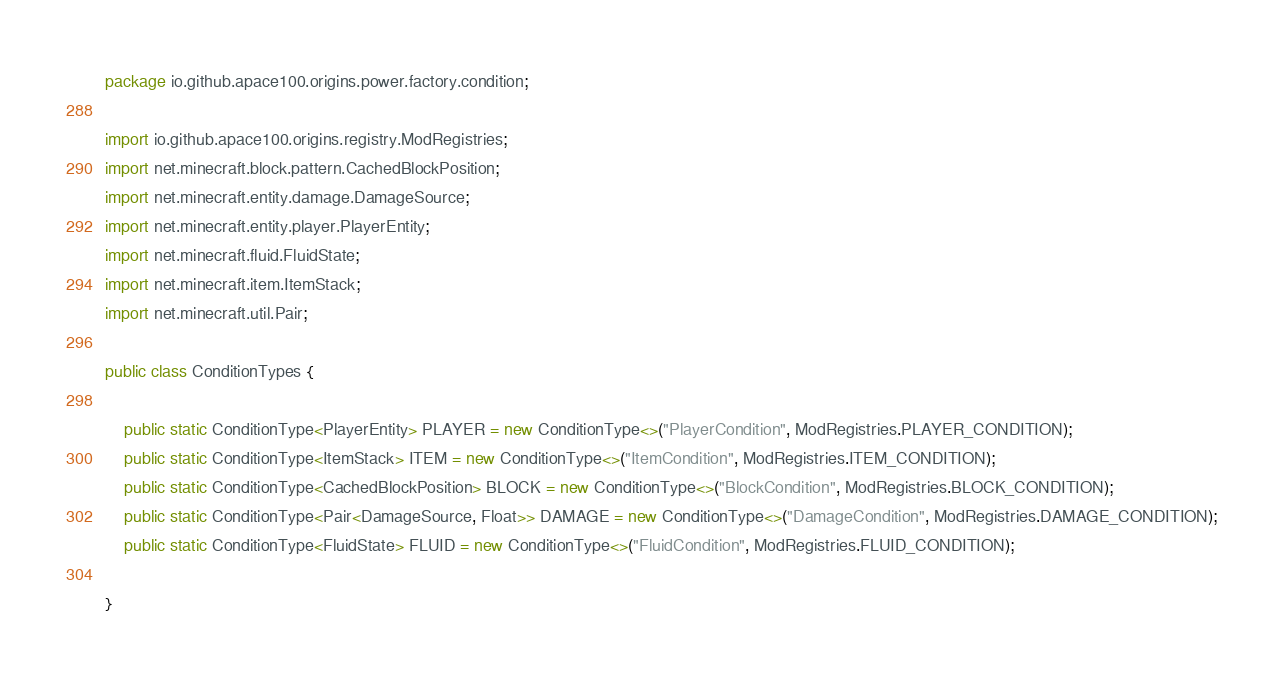Convert code to text. <code><loc_0><loc_0><loc_500><loc_500><_Java_>package io.github.apace100.origins.power.factory.condition;

import io.github.apace100.origins.registry.ModRegistries;
import net.minecraft.block.pattern.CachedBlockPosition;
import net.minecraft.entity.damage.DamageSource;
import net.minecraft.entity.player.PlayerEntity;
import net.minecraft.fluid.FluidState;
import net.minecraft.item.ItemStack;
import net.minecraft.util.Pair;

public class ConditionTypes {

    public static ConditionType<PlayerEntity> PLAYER = new ConditionType<>("PlayerCondition", ModRegistries.PLAYER_CONDITION);
    public static ConditionType<ItemStack> ITEM = new ConditionType<>("ItemCondition", ModRegistries.ITEM_CONDITION);
    public static ConditionType<CachedBlockPosition> BLOCK = new ConditionType<>("BlockCondition", ModRegistries.BLOCK_CONDITION);
    public static ConditionType<Pair<DamageSource, Float>> DAMAGE = new ConditionType<>("DamageCondition", ModRegistries.DAMAGE_CONDITION);
    public static ConditionType<FluidState> FLUID = new ConditionType<>("FluidCondition", ModRegistries.FLUID_CONDITION);

}
</code> 